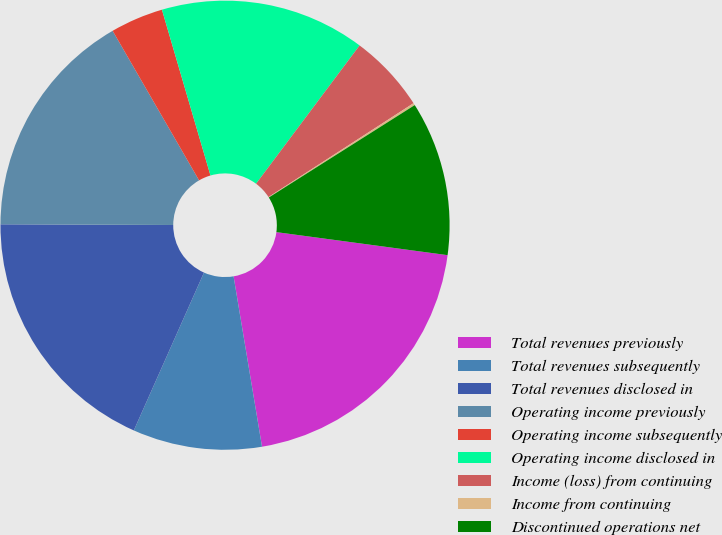<chart> <loc_0><loc_0><loc_500><loc_500><pie_chart><fcel>Total revenues previously<fcel>Total revenues subsequently<fcel>Total revenues disclosed in<fcel>Operating income previously<fcel>Operating income subsequently<fcel>Operating income disclosed in<fcel>Income (loss) from continuing<fcel>Income from continuing<fcel>Discontinued operations net<nl><fcel>20.24%<fcel>9.29%<fcel>18.41%<fcel>16.59%<fcel>3.81%<fcel>14.76%<fcel>5.63%<fcel>0.16%<fcel>11.11%<nl></chart> 